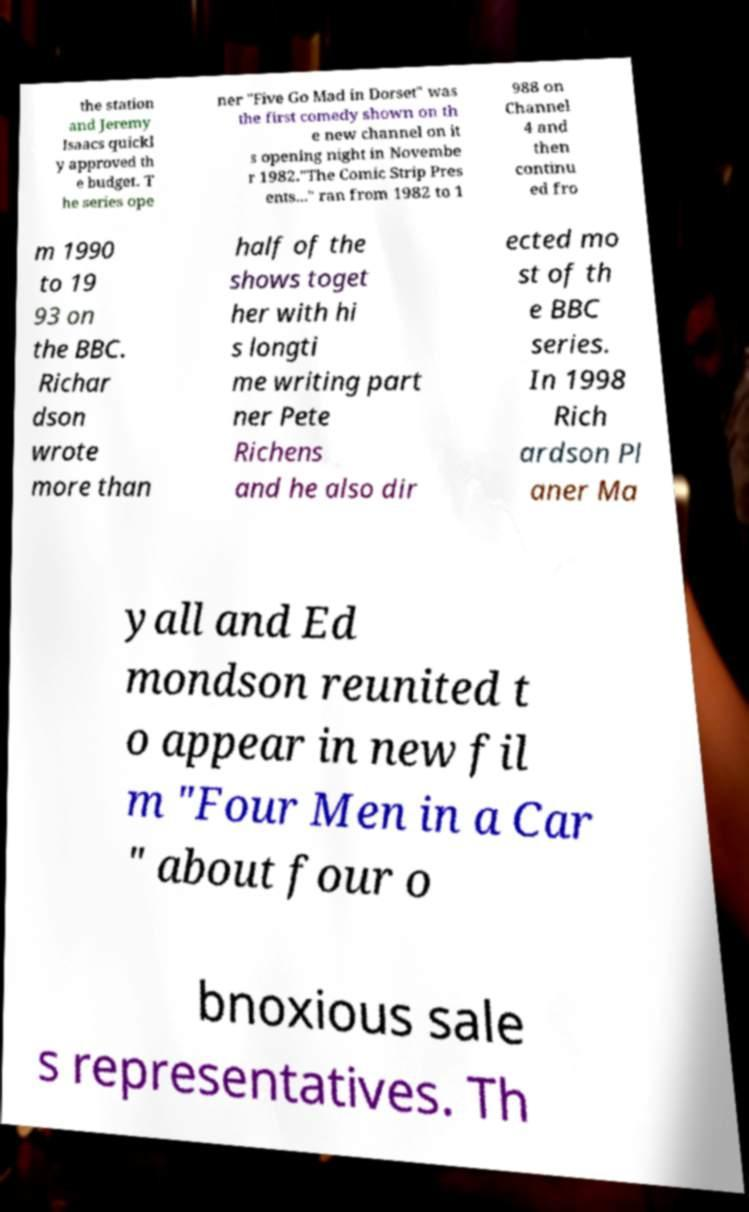I need the written content from this picture converted into text. Can you do that? the station and Jeremy Isaacs quickl y approved th e budget. T he series ope ner "Five Go Mad in Dorset" was the first comedy shown on th e new channel on it s opening night in Novembe r 1982."The Comic Strip Pres ents..." ran from 1982 to 1 988 on Channel 4 and then continu ed fro m 1990 to 19 93 on the BBC. Richar dson wrote more than half of the shows toget her with hi s longti me writing part ner Pete Richens and he also dir ected mo st of th e BBC series. In 1998 Rich ardson Pl aner Ma yall and Ed mondson reunited t o appear in new fil m "Four Men in a Car " about four o bnoxious sale s representatives. Th 